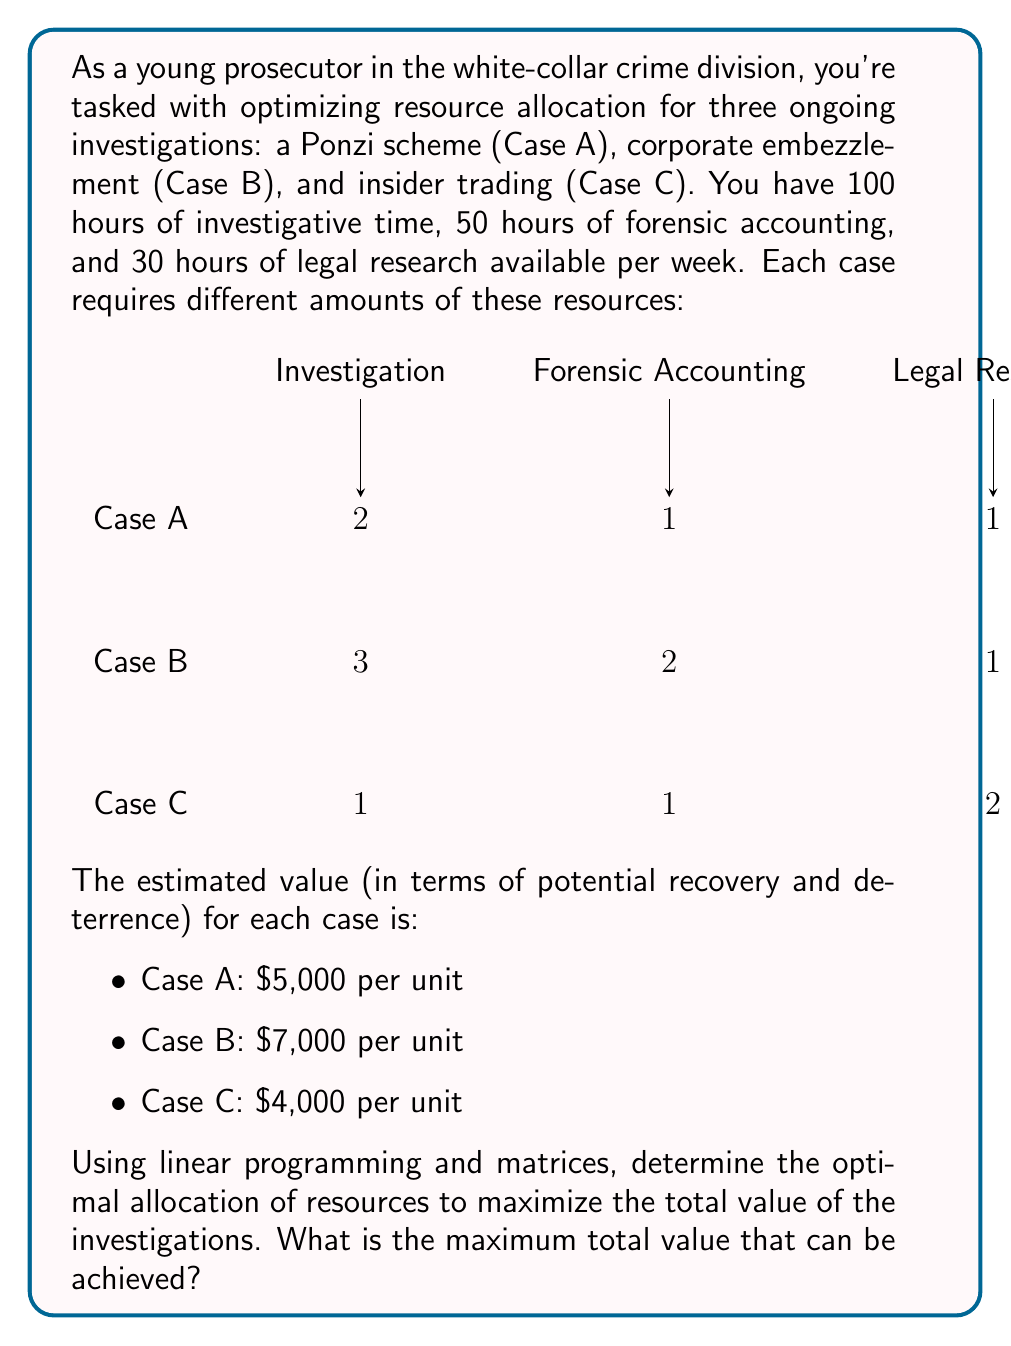Help me with this question. Let's approach this step-by-step using linear programming and matrices:

1) Define variables:
   Let $x$, $y$, and $z$ be the number of units pursued for Cases A, B, and C respectively.

2) Set up the objective function to maximize:
   $$ \text{Maximize } 5000x + 7000y + 4000z $$

3) Define constraints:
   Investigation time: $2x + 3y + z \leq 100$
   Forensic accounting: $x + 2y + z \leq 50$
   Legal research: $x + y + 2z \leq 30$
   Non-negativity: $x, y, z \geq 0$

4) Express in matrix form:
   $$ \begin{bmatrix}
   2 & 3 & 1 \\
   1 & 2 & 1 \\
   1 & 1 & 2
   \end{bmatrix}
   \begin{bmatrix}
   x \\ y \\ z
   \end{bmatrix}
   \leq
   \begin{bmatrix}
   100 \\ 50 \\ 30
   \end{bmatrix} $$

5) Solve using the simplex method or linear programming software. The optimal solution is:
   $x = 20$, $y = 15$, $z = 5$

6) Calculate the maximum value:
   $$ 5000(20) + 7000(15) + 4000(5) = 100000 + 105000 + 20000 = 225000 $$

Therefore, the maximum total value that can be achieved is $225,000.
Answer: $225,000 